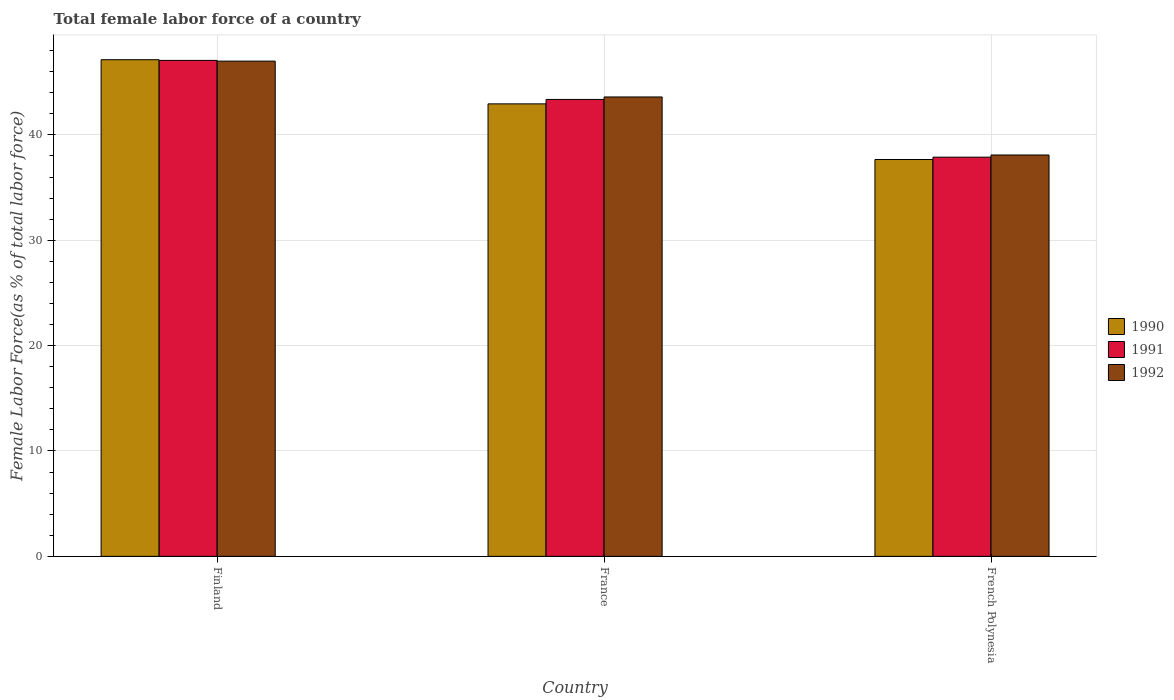Are the number of bars per tick equal to the number of legend labels?
Make the answer very short. Yes. How many bars are there on the 1st tick from the right?
Keep it short and to the point. 3. What is the percentage of female labor force in 1992 in Finland?
Your response must be concise. 47. Across all countries, what is the maximum percentage of female labor force in 1992?
Offer a terse response. 47. Across all countries, what is the minimum percentage of female labor force in 1992?
Your response must be concise. 38.09. In which country was the percentage of female labor force in 1991 maximum?
Give a very brief answer. Finland. In which country was the percentage of female labor force in 1992 minimum?
Provide a succinct answer. French Polynesia. What is the total percentage of female labor force in 1990 in the graph?
Offer a very short reply. 127.73. What is the difference between the percentage of female labor force in 1992 in Finland and that in French Polynesia?
Your answer should be compact. 8.91. What is the difference between the percentage of female labor force in 1990 in French Polynesia and the percentage of female labor force in 1992 in Finland?
Provide a short and direct response. -9.34. What is the average percentage of female labor force in 1991 per country?
Your answer should be compact. 42.77. What is the difference between the percentage of female labor force of/in 1991 and percentage of female labor force of/in 1992 in Finland?
Ensure brevity in your answer.  0.07. What is the ratio of the percentage of female labor force in 1992 in Finland to that in France?
Your response must be concise. 1.08. Is the difference between the percentage of female labor force in 1991 in Finland and French Polynesia greater than the difference between the percentage of female labor force in 1992 in Finland and French Polynesia?
Offer a very short reply. Yes. What is the difference between the highest and the second highest percentage of female labor force in 1992?
Your answer should be very brief. -5.51. What is the difference between the highest and the lowest percentage of female labor force in 1990?
Your answer should be very brief. 9.47. What is the difference between two consecutive major ticks on the Y-axis?
Offer a very short reply. 10. Does the graph contain grids?
Make the answer very short. Yes. How many legend labels are there?
Offer a very short reply. 3. What is the title of the graph?
Ensure brevity in your answer.  Total female labor force of a country. What is the label or title of the Y-axis?
Provide a succinct answer. Female Labor Force(as % of total labor force). What is the Female Labor Force(as % of total labor force) of 1990 in Finland?
Ensure brevity in your answer.  47.13. What is the Female Labor Force(as % of total labor force) of 1991 in Finland?
Your response must be concise. 47.07. What is the Female Labor Force(as % of total labor force) of 1992 in Finland?
Provide a succinct answer. 47. What is the Female Labor Force(as % of total labor force) in 1990 in France?
Your answer should be compact. 42.94. What is the Female Labor Force(as % of total labor force) of 1991 in France?
Your response must be concise. 43.36. What is the Female Labor Force(as % of total labor force) of 1992 in France?
Make the answer very short. 43.6. What is the Female Labor Force(as % of total labor force) of 1990 in French Polynesia?
Provide a short and direct response. 37.66. What is the Female Labor Force(as % of total labor force) of 1991 in French Polynesia?
Ensure brevity in your answer.  37.88. What is the Female Labor Force(as % of total labor force) of 1992 in French Polynesia?
Keep it short and to the point. 38.09. Across all countries, what is the maximum Female Labor Force(as % of total labor force) of 1990?
Your answer should be compact. 47.13. Across all countries, what is the maximum Female Labor Force(as % of total labor force) of 1991?
Keep it short and to the point. 47.07. Across all countries, what is the maximum Female Labor Force(as % of total labor force) in 1992?
Ensure brevity in your answer.  47. Across all countries, what is the minimum Female Labor Force(as % of total labor force) in 1990?
Offer a terse response. 37.66. Across all countries, what is the minimum Female Labor Force(as % of total labor force) in 1991?
Make the answer very short. 37.88. Across all countries, what is the minimum Female Labor Force(as % of total labor force) of 1992?
Make the answer very short. 38.09. What is the total Female Labor Force(as % of total labor force) in 1990 in the graph?
Offer a terse response. 127.73. What is the total Female Labor Force(as % of total labor force) in 1991 in the graph?
Offer a very short reply. 128.31. What is the total Female Labor Force(as % of total labor force) in 1992 in the graph?
Ensure brevity in your answer.  128.68. What is the difference between the Female Labor Force(as % of total labor force) of 1990 in Finland and that in France?
Offer a very short reply. 4.19. What is the difference between the Female Labor Force(as % of total labor force) of 1991 in Finland and that in France?
Ensure brevity in your answer.  3.7. What is the difference between the Female Labor Force(as % of total labor force) of 1992 in Finland and that in France?
Ensure brevity in your answer.  3.4. What is the difference between the Female Labor Force(as % of total labor force) of 1990 in Finland and that in French Polynesia?
Provide a succinct answer. 9.47. What is the difference between the Female Labor Force(as % of total labor force) in 1991 in Finland and that in French Polynesia?
Your answer should be compact. 9.18. What is the difference between the Female Labor Force(as % of total labor force) in 1992 in Finland and that in French Polynesia?
Make the answer very short. 8.91. What is the difference between the Female Labor Force(as % of total labor force) of 1990 in France and that in French Polynesia?
Offer a very short reply. 5.28. What is the difference between the Female Labor Force(as % of total labor force) of 1991 in France and that in French Polynesia?
Your answer should be compact. 5.48. What is the difference between the Female Labor Force(as % of total labor force) of 1992 in France and that in French Polynesia?
Your answer should be very brief. 5.51. What is the difference between the Female Labor Force(as % of total labor force) of 1990 in Finland and the Female Labor Force(as % of total labor force) of 1991 in France?
Provide a succinct answer. 3.77. What is the difference between the Female Labor Force(as % of total labor force) of 1990 in Finland and the Female Labor Force(as % of total labor force) of 1992 in France?
Ensure brevity in your answer.  3.54. What is the difference between the Female Labor Force(as % of total labor force) of 1991 in Finland and the Female Labor Force(as % of total labor force) of 1992 in France?
Provide a succinct answer. 3.47. What is the difference between the Female Labor Force(as % of total labor force) of 1990 in Finland and the Female Labor Force(as % of total labor force) of 1991 in French Polynesia?
Ensure brevity in your answer.  9.25. What is the difference between the Female Labor Force(as % of total labor force) of 1990 in Finland and the Female Labor Force(as % of total labor force) of 1992 in French Polynesia?
Give a very brief answer. 9.04. What is the difference between the Female Labor Force(as % of total labor force) in 1991 in Finland and the Female Labor Force(as % of total labor force) in 1992 in French Polynesia?
Provide a short and direct response. 8.98. What is the difference between the Female Labor Force(as % of total labor force) of 1990 in France and the Female Labor Force(as % of total labor force) of 1991 in French Polynesia?
Keep it short and to the point. 5.06. What is the difference between the Female Labor Force(as % of total labor force) of 1990 in France and the Female Labor Force(as % of total labor force) of 1992 in French Polynesia?
Ensure brevity in your answer.  4.85. What is the difference between the Female Labor Force(as % of total labor force) of 1991 in France and the Female Labor Force(as % of total labor force) of 1992 in French Polynesia?
Keep it short and to the point. 5.27. What is the average Female Labor Force(as % of total labor force) of 1990 per country?
Provide a short and direct response. 42.58. What is the average Female Labor Force(as % of total labor force) of 1991 per country?
Your answer should be very brief. 42.77. What is the average Female Labor Force(as % of total labor force) of 1992 per country?
Your answer should be compact. 42.89. What is the difference between the Female Labor Force(as % of total labor force) of 1990 and Female Labor Force(as % of total labor force) of 1991 in Finland?
Make the answer very short. 0.07. What is the difference between the Female Labor Force(as % of total labor force) of 1990 and Female Labor Force(as % of total labor force) of 1992 in Finland?
Give a very brief answer. 0.13. What is the difference between the Female Labor Force(as % of total labor force) of 1991 and Female Labor Force(as % of total labor force) of 1992 in Finland?
Ensure brevity in your answer.  0.07. What is the difference between the Female Labor Force(as % of total labor force) in 1990 and Female Labor Force(as % of total labor force) in 1991 in France?
Provide a short and direct response. -0.42. What is the difference between the Female Labor Force(as % of total labor force) of 1990 and Female Labor Force(as % of total labor force) of 1992 in France?
Provide a succinct answer. -0.65. What is the difference between the Female Labor Force(as % of total labor force) of 1991 and Female Labor Force(as % of total labor force) of 1992 in France?
Your response must be concise. -0.23. What is the difference between the Female Labor Force(as % of total labor force) of 1990 and Female Labor Force(as % of total labor force) of 1991 in French Polynesia?
Make the answer very short. -0.22. What is the difference between the Female Labor Force(as % of total labor force) in 1990 and Female Labor Force(as % of total labor force) in 1992 in French Polynesia?
Give a very brief answer. -0.43. What is the difference between the Female Labor Force(as % of total labor force) of 1991 and Female Labor Force(as % of total labor force) of 1992 in French Polynesia?
Give a very brief answer. -0.21. What is the ratio of the Female Labor Force(as % of total labor force) in 1990 in Finland to that in France?
Your response must be concise. 1.1. What is the ratio of the Female Labor Force(as % of total labor force) in 1991 in Finland to that in France?
Your answer should be very brief. 1.09. What is the ratio of the Female Labor Force(as % of total labor force) of 1992 in Finland to that in France?
Provide a succinct answer. 1.08. What is the ratio of the Female Labor Force(as % of total labor force) of 1990 in Finland to that in French Polynesia?
Keep it short and to the point. 1.25. What is the ratio of the Female Labor Force(as % of total labor force) in 1991 in Finland to that in French Polynesia?
Your answer should be compact. 1.24. What is the ratio of the Female Labor Force(as % of total labor force) of 1992 in Finland to that in French Polynesia?
Offer a terse response. 1.23. What is the ratio of the Female Labor Force(as % of total labor force) in 1990 in France to that in French Polynesia?
Give a very brief answer. 1.14. What is the ratio of the Female Labor Force(as % of total labor force) in 1991 in France to that in French Polynesia?
Your answer should be very brief. 1.14. What is the ratio of the Female Labor Force(as % of total labor force) in 1992 in France to that in French Polynesia?
Give a very brief answer. 1.14. What is the difference between the highest and the second highest Female Labor Force(as % of total labor force) of 1990?
Your answer should be compact. 4.19. What is the difference between the highest and the second highest Female Labor Force(as % of total labor force) in 1991?
Your answer should be compact. 3.7. What is the difference between the highest and the second highest Female Labor Force(as % of total labor force) in 1992?
Your answer should be very brief. 3.4. What is the difference between the highest and the lowest Female Labor Force(as % of total labor force) in 1990?
Provide a succinct answer. 9.47. What is the difference between the highest and the lowest Female Labor Force(as % of total labor force) in 1991?
Give a very brief answer. 9.18. What is the difference between the highest and the lowest Female Labor Force(as % of total labor force) of 1992?
Give a very brief answer. 8.91. 